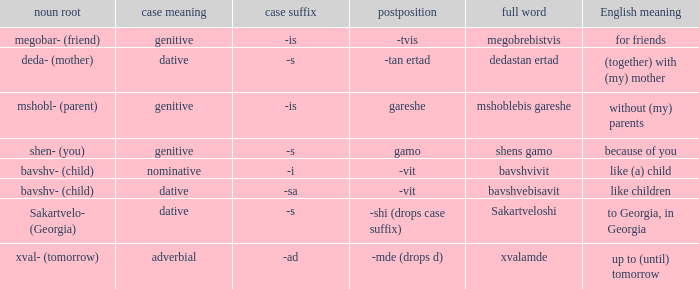What is Case Suffix (Case), when English Meaning is "to Georgia, in Georgia"? -s (dative). 